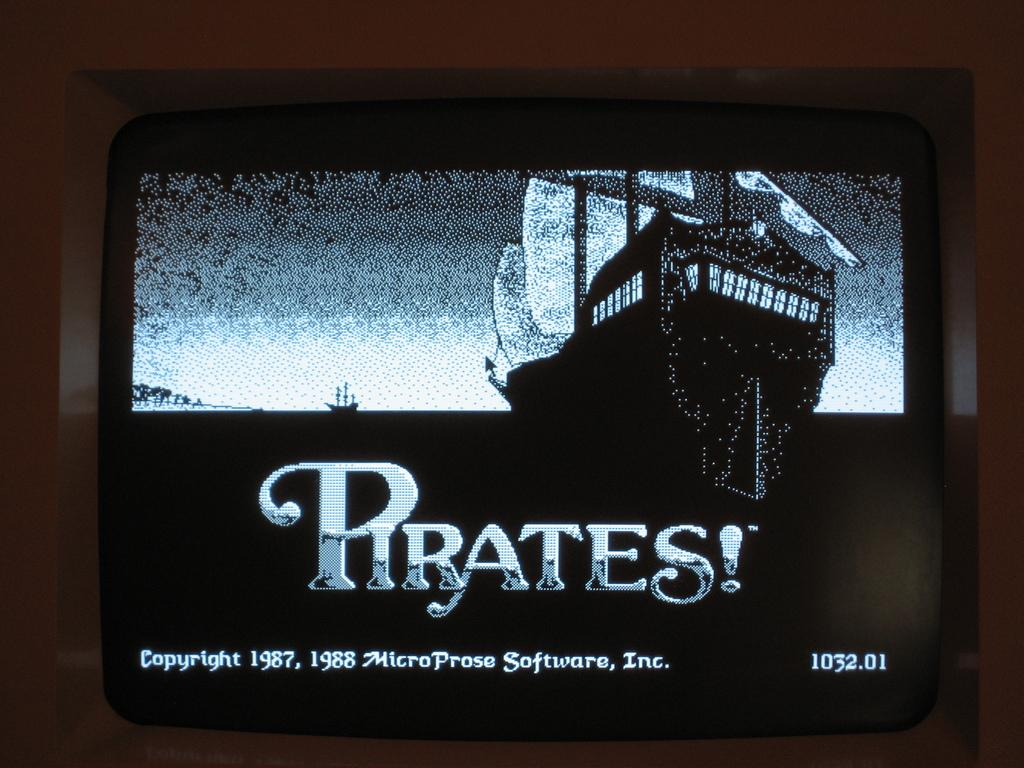<image>
Present a compact description of the photo's key features. An old television screen showing a game called Pirates 